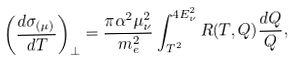<formula> <loc_0><loc_0><loc_500><loc_500>\left ( \frac { d \sigma _ { ( \mu ) } } { d T } \right ) _ { \perp } = \frac { \pi \alpha ^ { 2 } \mu _ { \nu } ^ { 2 } } { m _ { e } ^ { 2 } } \int _ { T ^ { 2 } } ^ { 4 E _ { \nu } ^ { 2 } } R ( T , Q ) \frac { d Q } { Q } ,</formula> 